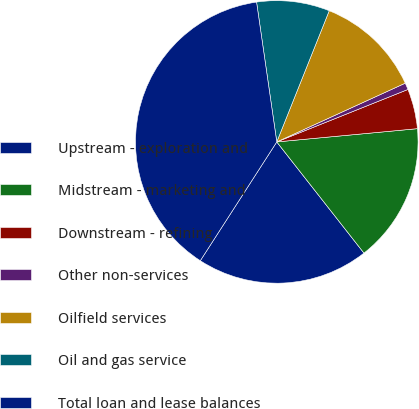Convert chart. <chart><loc_0><loc_0><loc_500><loc_500><pie_chart><fcel>Upstream - exploration and<fcel>Midstream - marketing and<fcel>Downstream - refining<fcel>Other non-services<fcel>Oilfield services<fcel>Oil and gas service<fcel>Total loan and lease balances<nl><fcel>19.69%<fcel>15.91%<fcel>4.56%<fcel>0.77%<fcel>12.12%<fcel>8.34%<fcel>38.61%<nl></chart> 